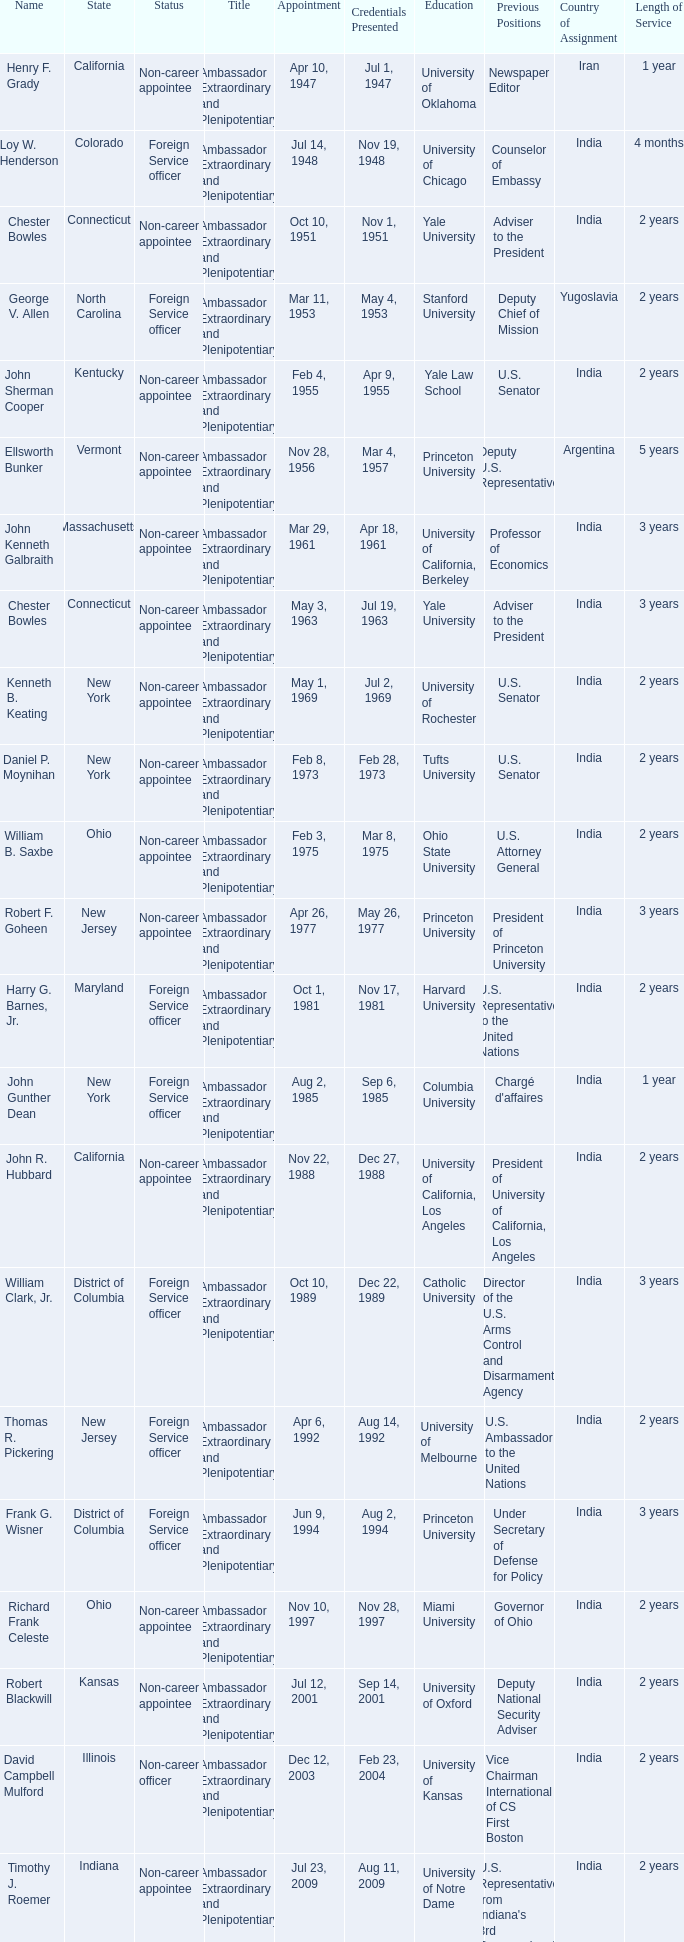What state has an appointment for jul 12, 2001? Kansas. 